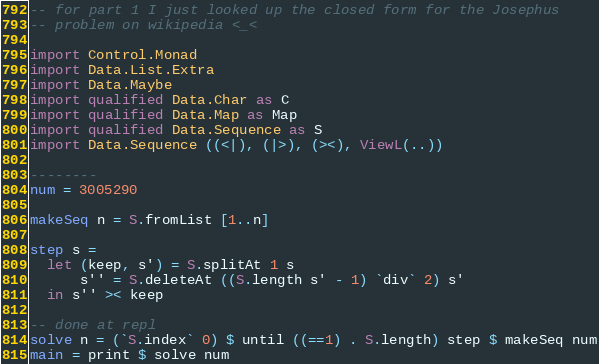<code> <loc_0><loc_0><loc_500><loc_500><_Haskell_>-- for part 1 I just looked up the closed form for the Josephus
-- problem on wikipedia <_<

import Control.Monad
import Data.List.Extra
import Data.Maybe
import qualified Data.Char as C
import qualified Data.Map as Map
import qualified Data.Sequence as S
import Data.Sequence ((<|), (|>), (><), ViewL(..))

--------
num = 3005290

makeSeq n = S.fromList [1..n]

step s =
  let (keep, s') = S.splitAt 1 s
      s'' = S.deleteAt ((S.length s' - 1) `div` 2) s'
  in s'' >< keep

-- done at repl
solve n = (`S.index` 0) $ until ((==1) . S.length) step $ makeSeq num
main = print $ solve num
</code> 